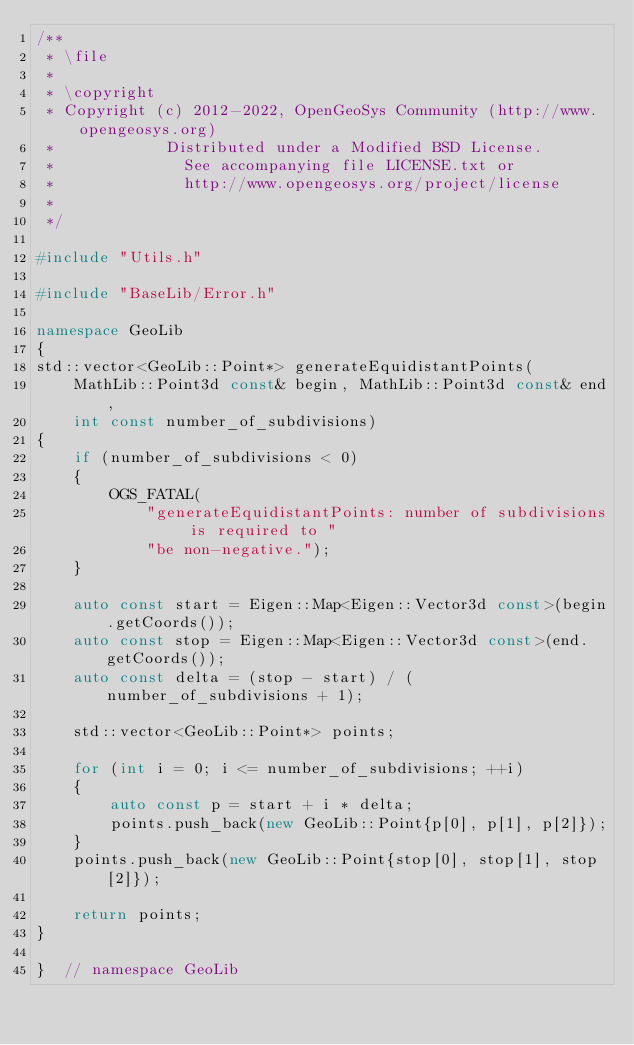Convert code to text. <code><loc_0><loc_0><loc_500><loc_500><_C++_>/**
 * \file
 *
 * \copyright
 * Copyright (c) 2012-2022, OpenGeoSys Community (http://www.opengeosys.org)
 *            Distributed under a Modified BSD License.
 *              See accompanying file LICENSE.txt or
 *              http://www.opengeosys.org/project/license
 *
 */

#include "Utils.h"

#include "BaseLib/Error.h"

namespace GeoLib
{
std::vector<GeoLib::Point*> generateEquidistantPoints(
    MathLib::Point3d const& begin, MathLib::Point3d const& end,
    int const number_of_subdivisions)
{
    if (number_of_subdivisions < 0)
    {
        OGS_FATAL(
            "generateEquidistantPoints: number of subdivisions is required to "
            "be non-negative.");
    }

    auto const start = Eigen::Map<Eigen::Vector3d const>(begin.getCoords());
    auto const stop = Eigen::Map<Eigen::Vector3d const>(end.getCoords());
    auto const delta = (stop - start) / (number_of_subdivisions + 1);

    std::vector<GeoLib::Point*> points;

    for (int i = 0; i <= number_of_subdivisions; ++i)
    {
        auto const p = start + i * delta;
        points.push_back(new GeoLib::Point{p[0], p[1], p[2]});
    }
    points.push_back(new GeoLib::Point{stop[0], stop[1], stop[2]});

    return points;
}

}  // namespace GeoLib
</code> 